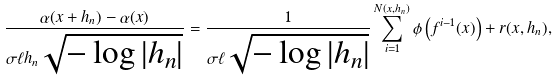<formula> <loc_0><loc_0><loc_500><loc_500>\frac { \alpha ( x + h _ { n } ) - \alpha ( x ) } { \sigma \ell h _ { n } \sqrt { - \log | h _ { n } | } } = \frac { 1 } { \sigma \ell \sqrt { - \log | h _ { n } | } } \sum _ { i = 1 } ^ { N ( x , h _ { n } ) } \phi \left ( f ^ { i - 1 } ( x ) \right ) + r ( x , h _ { n } ) ,</formula> 